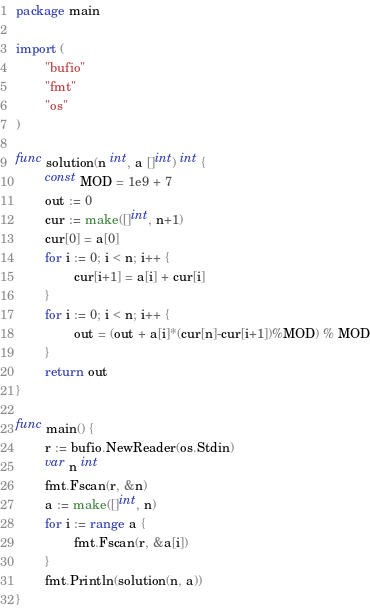<code> <loc_0><loc_0><loc_500><loc_500><_Go_>package main

import (
        "bufio"
        "fmt"
        "os"
)

func solution(n int, a []int) int {
        const MOD = 1e9 + 7
        out := 0
        cur := make([]int, n+1)
        cur[0] = a[0]
        for i := 0; i < n; i++ {
                cur[i+1] = a[i] + cur[i]
        }
        for i := 0; i < n; i++ {
                out = (out + a[i]*(cur[n]-cur[i+1])%MOD) % MOD
        }
        return out
}

func main() {
        r := bufio.NewReader(os.Stdin)
        var n int
        fmt.Fscan(r, &n)
        a := make([]int, n)
        for i := range a {
                fmt.Fscan(r, &a[i])
        }
        fmt.Println(solution(n, a))
}</code> 